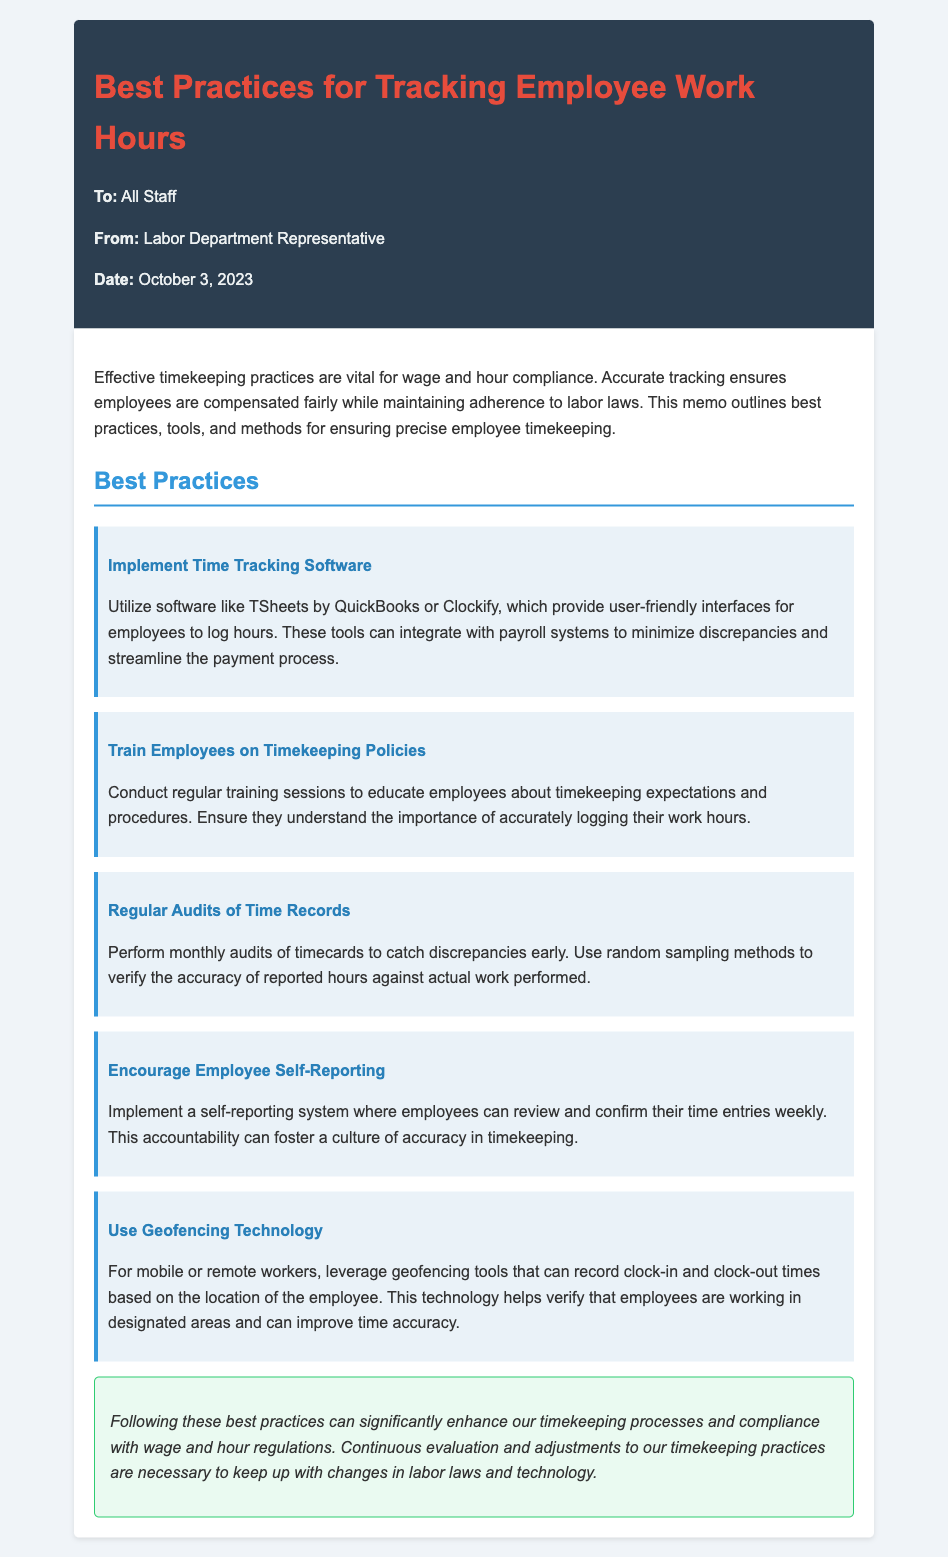What is the date of the memo? The date of the memo is provided in the header section, which states it was issued on October 3, 2023.
Answer: October 3, 2023 Who is the memo addressed to? The recipient of the memo is indicated at the top, where it states it is addressed to "All Staff."
Answer: All Staff What software is recommended for time tracking? The memo suggests using specific software, including TSheets by QuickBooks and Clockify, for effective time tracking practices.
Answer: TSheets by QuickBooks or Clockify What is one method for ensuring accurate timekeeping mentioned in the memo? The document lists various best practices, one of which is to conduct "Regular Audits of Time Records" to check for discrepancies.
Answer: Regular Audits of Time Records How often should audits of time records be performed? The memo specifies that audits of time records should be conducted on a monthly basis to ensure accuracy.
Answer: Monthly What does the memo suggest for mobile or remote workers regarding time tracking? It mentions the use of geofencing technology specifically for mobile or remote workers to verify their clock-in and clock-out times based on location.
Answer: Geofencing technology What is one benefit of encouraging employee self-reporting? The memo highlights that self-reporting can foster a culture of accuracy in timekeeping among employees, enhancing accountability.
Answer: Accountability What color is used for the memo header? The memo uses a background color of dark blue (#2c3e50) for the header section, which contains the title and address information.
Answer: Dark blue 